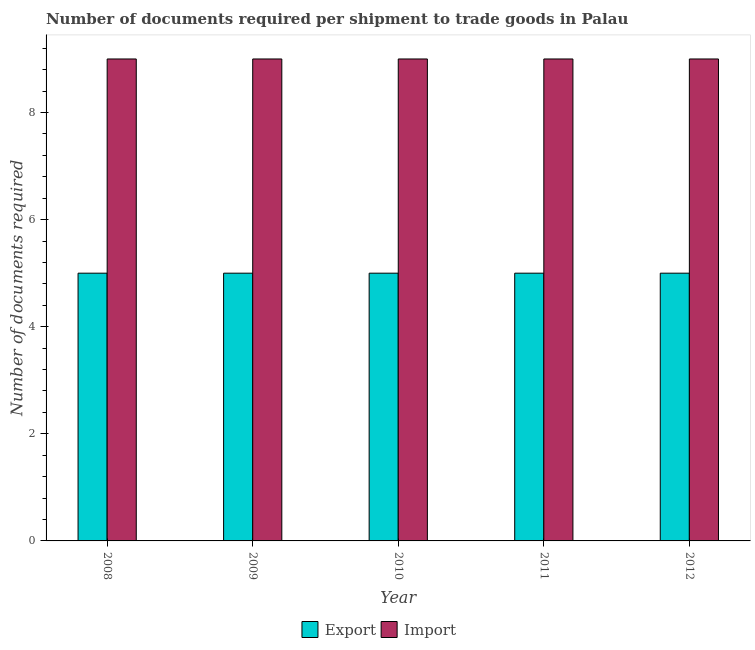How many different coloured bars are there?
Your answer should be compact. 2. Are the number of bars per tick equal to the number of legend labels?
Provide a succinct answer. Yes. How many bars are there on the 1st tick from the right?
Your response must be concise. 2. What is the number of documents required to import goods in 2009?
Ensure brevity in your answer.  9. Across all years, what is the maximum number of documents required to import goods?
Your answer should be very brief. 9. Across all years, what is the minimum number of documents required to import goods?
Your answer should be very brief. 9. In which year was the number of documents required to export goods maximum?
Offer a terse response. 2008. What is the total number of documents required to export goods in the graph?
Give a very brief answer. 25. In the year 2010, what is the difference between the number of documents required to import goods and number of documents required to export goods?
Provide a short and direct response. 0. What is the ratio of the number of documents required to export goods in 2008 to that in 2009?
Offer a terse response. 1. Is the number of documents required to import goods in 2010 less than that in 2011?
Keep it short and to the point. No. Is the difference between the number of documents required to export goods in 2010 and 2012 greater than the difference between the number of documents required to import goods in 2010 and 2012?
Offer a very short reply. No. What is the difference between the highest and the second highest number of documents required to import goods?
Provide a short and direct response. 0. What does the 1st bar from the left in 2009 represents?
Provide a succinct answer. Export. What does the 2nd bar from the right in 2012 represents?
Ensure brevity in your answer.  Export. Are all the bars in the graph horizontal?
Ensure brevity in your answer.  No. How many years are there in the graph?
Offer a terse response. 5. Does the graph contain any zero values?
Your response must be concise. No. Does the graph contain grids?
Your answer should be compact. No. How are the legend labels stacked?
Provide a succinct answer. Horizontal. What is the title of the graph?
Your answer should be very brief. Number of documents required per shipment to trade goods in Palau. What is the label or title of the X-axis?
Give a very brief answer. Year. What is the label or title of the Y-axis?
Your response must be concise. Number of documents required. What is the Number of documents required of Export in 2008?
Offer a very short reply. 5. What is the Number of documents required in Import in 2012?
Provide a short and direct response. 9. Across all years, what is the maximum Number of documents required of Import?
Offer a terse response. 9. Across all years, what is the minimum Number of documents required in Export?
Your answer should be very brief. 5. Across all years, what is the minimum Number of documents required of Import?
Provide a short and direct response. 9. What is the total Number of documents required of Export in the graph?
Provide a short and direct response. 25. What is the total Number of documents required in Import in the graph?
Give a very brief answer. 45. What is the difference between the Number of documents required in Import in 2008 and that in 2009?
Keep it short and to the point. 0. What is the difference between the Number of documents required of Export in 2008 and that in 2010?
Your answer should be very brief. 0. What is the difference between the Number of documents required of Import in 2008 and that in 2010?
Offer a terse response. 0. What is the difference between the Number of documents required of Import in 2008 and that in 2011?
Make the answer very short. 0. What is the difference between the Number of documents required of Export in 2008 and that in 2012?
Offer a terse response. 0. What is the difference between the Number of documents required in Import in 2008 and that in 2012?
Make the answer very short. 0. What is the difference between the Number of documents required of Export in 2009 and that in 2011?
Give a very brief answer. 0. What is the difference between the Number of documents required in Import in 2009 and that in 2011?
Offer a terse response. 0. What is the difference between the Number of documents required of Export in 2009 and that in 2012?
Make the answer very short. 0. What is the difference between the Number of documents required in Export in 2010 and that in 2011?
Ensure brevity in your answer.  0. What is the difference between the Number of documents required of Import in 2010 and that in 2011?
Make the answer very short. 0. What is the difference between the Number of documents required of Export in 2010 and that in 2012?
Give a very brief answer. 0. What is the difference between the Number of documents required of Import in 2010 and that in 2012?
Provide a short and direct response. 0. What is the difference between the Number of documents required of Export in 2008 and the Number of documents required of Import in 2012?
Provide a short and direct response. -4. What is the difference between the Number of documents required in Export in 2010 and the Number of documents required in Import in 2011?
Make the answer very short. -4. What is the difference between the Number of documents required of Export in 2011 and the Number of documents required of Import in 2012?
Offer a terse response. -4. In the year 2010, what is the difference between the Number of documents required in Export and Number of documents required in Import?
Keep it short and to the point. -4. In the year 2012, what is the difference between the Number of documents required of Export and Number of documents required of Import?
Provide a succinct answer. -4. What is the ratio of the Number of documents required in Export in 2008 to that in 2011?
Offer a very short reply. 1. What is the ratio of the Number of documents required of Import in 2008 to that in 2011?
Give a very brief answer. 1. What is the ratio of the Number of documents required in Import in 2008 to that in 2012?
Offer a terse response. 1. What is the ratio of the Number of documents required of Export in 2009 to that in 2011?
Your answer should be compact. 1. What is the ratio of the Number of documents required in Import in 2009 to that in 2012?
Your answer should be compact. 1. What is the ratio of the Number of documents required of Import in 2010 to that in 2011?
Give a very brief answer. 1. What is the ratio of the Number of documents required of Import in 2010 to that in 2012?
Offer a terse response. 1. What is the ratio of the Number of documents required in Export in 2011 to that in 2012?
Provide a succinct answer. 1. What is the ratio of the Number of documents required in Import in 2011 to that in 2012?
Provide a short and direct response. 1. What is the difference between the highest and the second highest Number of documents required in Export?
Offer a terse response. 0. 